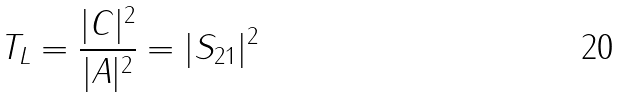<formula> <loc_0><loc_0><loc_500><loc_500>T _ { L } = \frac { | C | ^ { 2 } } { | A | ^ { 2 } } = | S _ { 2 1 } | ^ { 2 }</formula> 